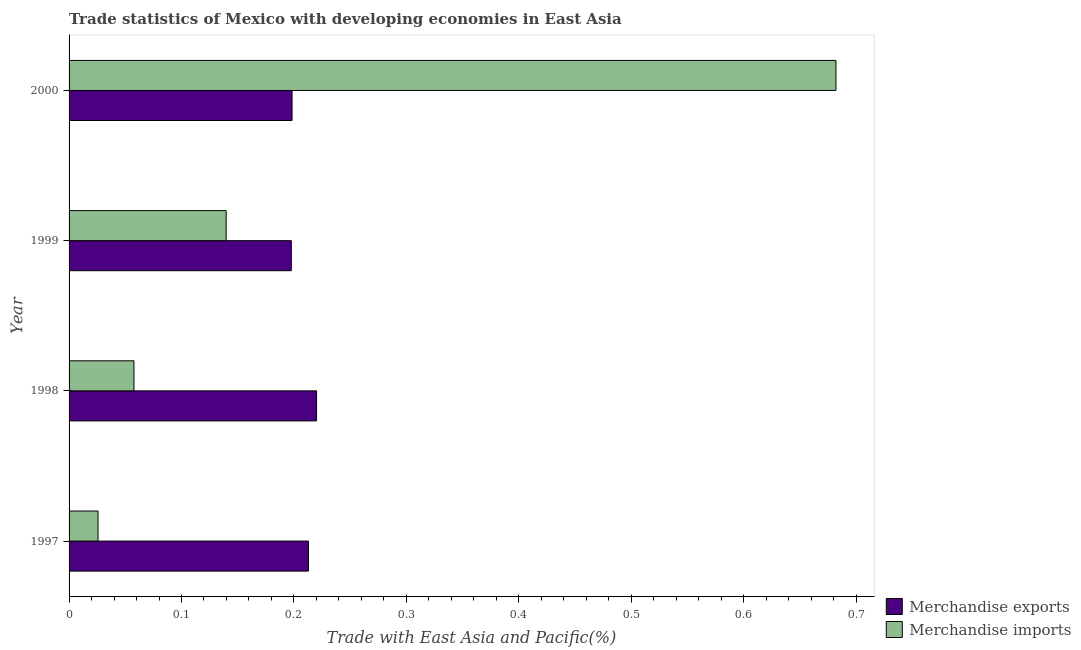How many different coloured bars are there?
Your answer should be very brief. 2. How many bars are there on the 4th tick from the top?
Offer a very short reply. 2. How many bars are there on the 4th tick from the bottom?
Ensure brevity in your answer.  2. What is the label of the 4th group of bars from the top?
Give a very brief answer. 1997. What is the merchandise imports in 1998?
Provide a short and direct response. 0.06. Across all years, what is the maximum merchandise exports?
Keep it short and to the point. 0.22. Across all years, what is the minimum merchandise exports?
Your answer should be very brief. 0.2. In which year was the merchandise exports maximum?
Your answer should be compact. 1998. In which year was the merchandise imports minimum?
Give a very brief answer. 1997. What is the total merchandise imports in the graph?
Provide a succinct answer. 0.91. What is the difference between the merchandise exports in 1999 and that in 2000?
Your answer should be very brief. -0. What is the difference between the merchandise exports in 1998 and the merchandise imports in 1997?
Give a very brief answer. 0.19. What is the average merchandise exports per year?
Your response must be concise. 0.21. In the year 1998, what is the difference between the merchandise exports and merchandise imports?
Provide a succinct answer. 0.16. In how many years, is the merchandise imports greater than 0.58 %?
Keep it short and to the point. 1. What is the ratio of the merchandise exports in 1998 to that in 1999?
Ensure brevity in your answer.  1.11. What is the difference between the highest and the second highest merchandise exports?
Ensure brevity in your answer.  0.01. What is the difference between the highest and the lowest merchandise imports?
Offer a very short reply. 0.66. Is the sum of the merchandise imports in 1997 and 1999 greater than the maximum merchandise exports across all years?
Your answer should be very brief. No. What does the 2nd bar from the top in 1998 represents?
Give a very brief answer. Merchandise exports. How many bars are there?
Provide a succinct answer. 8. How many years are there in the graph?
Ensure brevity in your answer.  4. Are the values on the major ticks of X-axis written in scientific E-notation?
Keep it short and to the point. No. Where does the legend appear in the graph?
Make the answer very short. Bottom right. How many legend labels are there?
Provide a short and direct response. 2. What is the title of the graph?
Your answer should be very brief. Trade statistics of Mexico with developing economies in East Asia. What is the label or title of the X-axis?
Your response must be concise. Trade with East Asia and Pacific(%). What is the Trade with East Asia and Pacific(%) of Merchandise exports in 1997?
Your answer should be compact. 0.21. What is the Trade with East Asia and Pacific(%) in Merchandise imports in 1997?
Make the answer very short. 0.03. What is the Trade with East Asia and Pacific(%) of Merchandise exports in 1998?
Provide a succinct answer. 0.22. What is the Trade with East Asia and Pacific(%) of Merchandise imports in 1998?
Your answer should be compact. 0.06. What is the Trade with East Asia and Pacific(%) of Merchandise exports in 1999?
Offer a very short reply. 0.2. What is the Trade with East Asia and Pacific(%) in Merchandise imports in 1999?
Make the answer very short. 0.14. What is the Trade with East Asia and Pacific(%) in Merchandise exports in 2000?
Offer a terse response. 0.2. What is the Trade with East Asia and Pacific(%) in Merchandise imports in 2000?
Your answer should be compact. 0.68. Across all years, what is the maximum Trade with East Asia and Pacific(%) of Merchandise exports?
Provide a short and direct response. 0.22. Across all years, what is the maximum Trade with East Asia and Pacific(%) of Merchandise imports?
Make the answer very short. 0.68. Across all years, what is the minimum Trade with East Asia and Pacific(%) of Merchandise exports?
Offer a terse response. 0.2. Across all years, what is the minimum Trade with East Asia and Pacific(%) in Merchandise imports?
Keep it short and to the point. 0.03. What is the total Trade with East Asia and Pacific(%) in Merchandise exports in the graph?
Your answer should be very brief. 0.83. What is the total Trade with East Asia and Pacific(%) in Merchandise imports in the graph?
Give a very brief answer. 0.91. What is the difference between the Trade with East Asia and Pacific(%) of Merchandise exports in 1997 and that in 1998?
Provide a succinct answer. -0.01. What is the difference between the Trade with East Asia and Pacific(%) in Merchandise imports in 1997 and that in 1998?
Ensure brevity in your answer.  -0.03. What is the difference between the Trade with East Asia and Pacific(%) in Merchandise exports in 1997 and that in 1999?
Your answer should be compact. 0.02. What is the difference between the Trade with East Asia and Pacific(%) of Merchandise imports in 1997 and that in 1999?
Provide a short and direct response. -0.11. What is the difference between the Trade with East Asia and Pacific(%) of Merchandise exports in 1997 and that in 2000?
Your answer should be compact. 0.01. What is the difference between the Trade with East Asia and Pacific(%) of Merchandise imports in 1997 and that in 2000?
Ensure brevity in your answer.  -0.66. What is the difference between the Trade with East Asia and Pacific(%) in Merchandise exports in 1998 and that in 1999?
Provide a short and direct response. 0.02. What is the difference between the Trade with East Asia and Pacific(%) in Merchandise imports in 1998 and that in 1999?
Offer a terse response. -0.08. What is the difference between the Trade with East Asia and Pacific(%) of Merchandise exports in 1998 and that in 2000?
Keep it short and to the point. 0.02. What is the difference between the Trade with East Asia and Pacific(%) of Merchandise imports in 1998 and that in 2000?
Your response must be concise. -0.62. What is the difference between the Trade with East Asia and Pacific(%) of Merchandise exports in 1999 and that in 2000?
Provide a short and direct response. -0. What is the difference between the Trade with East Asia and Pacific(%) of Merchandise imports in 1999 and that in 2000?
Ensure brevity in your answer.  -0.54. What is the difference between the Trade with East Asia and Pacific(%) of Merchandise exports in 1997 and the Trade with East Asia and Pacific(%) of Merchandise imports in 1998?
Your response must be concise. 0.16. What is the difference between the Trade with East Asia and Pacific(%) of Merchandise exports in 1997 and the Trade with East Asia and Pacific(%) of Merchandise imports in 1999?
Provide a succinct answer. 0.07. What is the difference between the Trade with East Asia and Pacific(%) of Merchandise exports in 1997 and the Trade with East Asia and Pacific(%) of Merchandise imports in 2000?
Give a very brief answer. -0.47. What is the difference between the Trade with East Asia and Pacific(%) of Merchandise exports in 1998 and the Trade with East Asia and Pacific(%) of Merchandise imports in 1999?
Offer a very short reply. 0.08. What is the difference between the Trade with East Asia and Pacific(%) in Merchandise exports in 1998 and the Trade with East Asia and Pacific(%) in Merchandise imports in 2000?
Your answer should be compact. -0.46. What is the difference between the Trade with East Asia and Pacific(%) in Merchandise exports in 1999 and the Trade with East Asia and Pacific(%) in Merchandise imports in 2000?
Offer a terse response. -0.48. What is the average Trade with East Asia and Pacific(%) of Merchandise exports per year?
Provide a succinct answer. 0.21. What is the average Trade with East Asia and Pacific(%) in Merchandise imports per year?
Give a very brief answer. 0.23. In the year 1997, what is the difference between the Trade with East Asia and Pacific(%) of Merchandise exports and Trade with East Asia and Pacific(%) of Merchandise imports?
Your answer should be very brief. 0.19. In the year 1998, what is the difference between the Trade with East Asia and Pacific(%) of Merchandise exports and Trade with East Asia and Pacific(%) of Merchandise imports?
Provide a succinct answer. 0.16. In the year 1999, what is the difference between the Trade with East Asia and Pacific(%) in Merchandise exports and Trade with East Asia and Pacific(%) in Merchandise imports?
Give a very brief answer. 0.06. In the year 2000, what is the difference between the Trade with East Asia and Pacific(%) of Merchandise exports and Trade with East Asia and Pacific(%) of Merchandise imports?
Offer a terse response. -0.48. What is the ratio of the Trade with East Asia and Pacific(%) in Merchandise exports in 1997 to that in 1998?
Give a very brief answer. 0.97. What is the ratio of the Trade with East Asia and Pacific(%) of Merchandise imports in 1997 to that in 1998?
Offer a very short reply. 0.45. What is the ratio of the Trade with East Asia and Pacific(%) in Merchandise exports in 1997 to that in 1999?
Ensure brevity in your answer.  1.08. What is the ratio of the Trade with East Asia and Pacific(%) of Merchandise imports in 1997 to that in 1999?
Ensure brevity in your answer.  0.18. What is the ratio of the Trade with East Asia and Pacific(%) of Merchandise exports in 1997 to that in 2000?
Provide a succinct answer. 1.07. What is the ratio of the Trade with East Asia and Pacific(%) in Merchandise imports in 1997 to that in 2000?
Provide a short and direct response. 0.04. What is the ratio of the Trade with East Asia and Pacific(%) of Merchandise exports in 1998 to that in 1999?
Provide a short and direct response. 1.11. What is the ratio of the Trade with East Asia and Pacific(%) of Merchandise imports in 1998 to that in 1999?
Ensure brevity in your answer.  0.41. What is the ratio of the Trade with East Asia and Pacific(%) of Merchandise exports in 1998 to that in 2000?
Offer a terse response. 1.11. What is the ratio of the Trade with East Asia and Pacific(%) of Merchandise imports in 1998 to that in 2000?
Your answer should be very brief. 0.08. What is the ratio of the Trade with East Asia and Pacific(%) in Merchandise exports in 1999 to that in 2000?
Give a very brief answer. 1. What is the ratio of the Trade with East Asia and Pacific(%) in Merchandise imports in 1999 to that in 2000?
Keep it short and to the point. 0.2. What is the difference between the highest and the second highest Trade with East Asia and Pacific(%) of Merchandise exports?
Keep it short and to the point. 0.01. What is the difference between the highest and the second highest Trade with East Asia and Pacific(%) of Merchandise imports?
Provide a succinct answer. 0.54. What is the difference between the highest and the lowest Trade with East Asia and Pacific(%) in Merchandise exports?
Offer a very short reply. 0.02. What is the difference between the highest and the lowest Trade with East Asia and Pacific(%) in Merchandise imports?
Your answer should be compact. 0.66. 